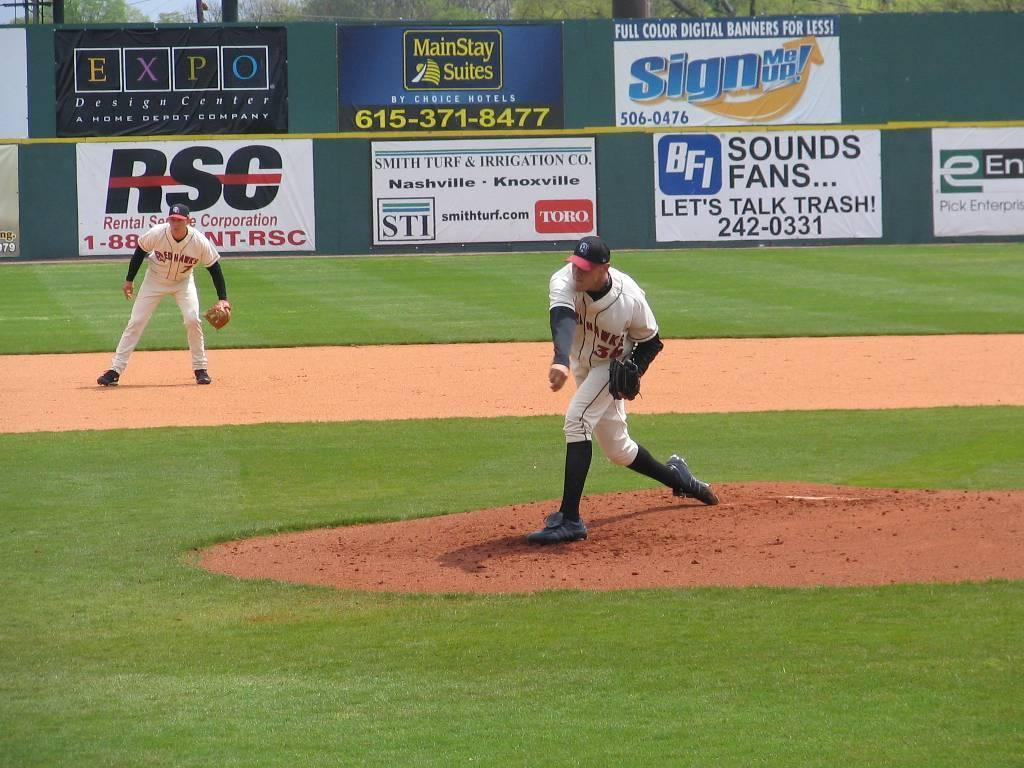Provide a one-sentence caption for the provided image. a man pitching with a sign in the back saying sign me up. 